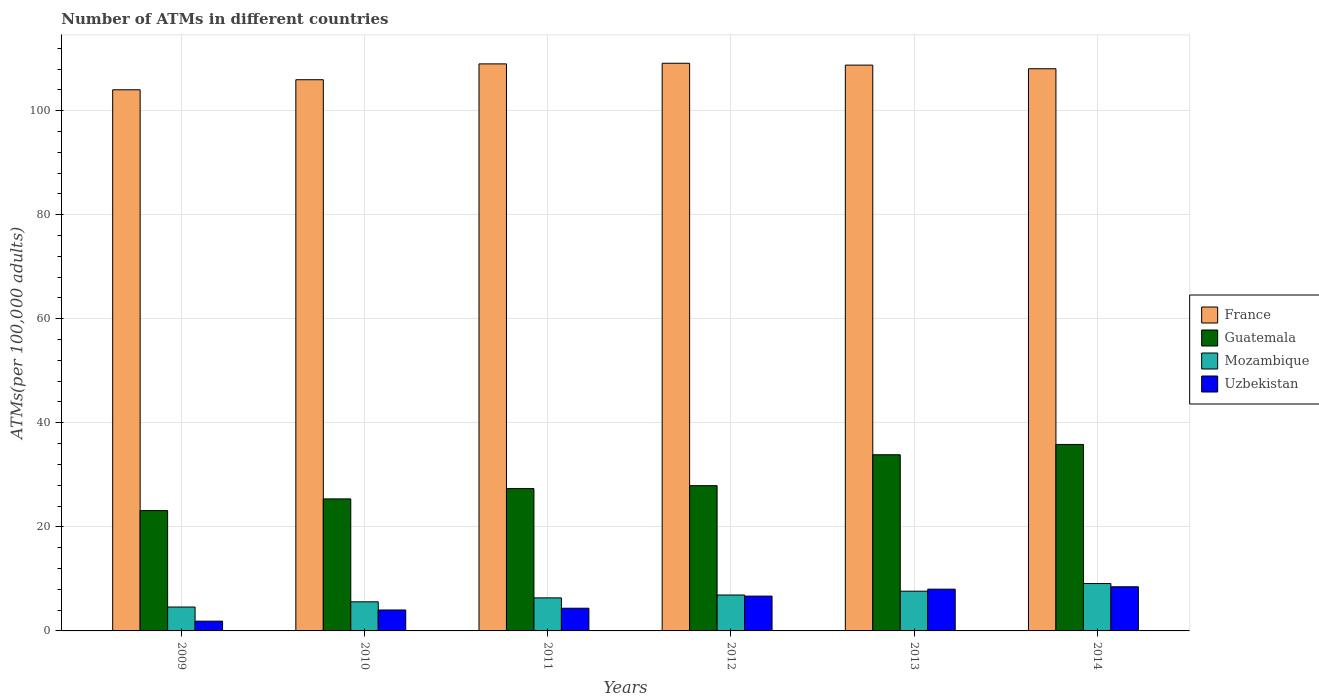How many groups of bars are there?
Offer a terse response. 6. How many bars are there on the 2nd tick from the right?
Give a very brief answer. 4. What is the number of ATMs in Mozambique in 2012?
Offer a terse response. 6.9. Across all years, what is the maximum number of ATMs in Mozambique?
Ensure brevity in your answer.  9.11. Across all years, what is the minimum number of ATMs in Uzbekistan?
Provide a short and direct response. 1.88. In which year was the number of ATMs in Uzbekistan maximum?
Your response must be concise. 2014. In which year was the number of ATMs in Guatemala minimum?
Ensure brevity in your answer.  2009. What is the total number of ATMs in Uzbekistan in the graph?
Offer a very short reply. 33.47. What is the difference between the number of ATMs in Guatemala in 2010 and that in 2012?
Your answer should be very brief. -2.55. What is the difference between the number of ATMs in Uzbekistan in 2010 and the number of ATMs in Mozambique in 2013?
Provide a succinct answer. -3.62. What is the average number of ATMs in Guatemala per year?
Your answer should be very brief. 28.91. In the year 2013, what is the difference between the number of ATMs in Guatemala and number of ATMs in Uzbekistan?
Offer a terse response. 25.83. What is the ratio of the number of ATMs in Uzbekistan in 2010 to that in 2014?
Offer a very short reply. 0.47. Is the difference between the number of ATMs in Guatemala in 2009 and 2014 greater than the difference between the number of ATMs in Uzbekistan in 2009 and 2014?
Offer a terse response. No. What is the difference between the highest and the second highest number of ATMs in France?
Ensure brevity in your answer.  0.12. What is the difference between the highest and the lowest number of ATMs in Mozambique?
Keep it short and to the point. 4.51. In how many years, is the number of ATMs in France greater than the average number of ATMs in France taken over all years?
Offer a very short reply. 4. Is the sum of the number of ATMs in France in 2011 and 2012 greater than the maximum number of ATMs in Guatemala across all years?
Your response must be concise. Yes. What does the 2nd bar from the left in 2010 represents?
Provide a short and direct response. Guatemala. Is it the case that in every year, the sum of the number of ATMs in Guatemala and number of ATMs in France is greater than the number of ATMs in Mozambique?
Provide a succinct answer. Yes. Are all the bars in the graph horizontal?
Ensure brevity in your answer.  No. Are the values on the major ticks of Y-axis written in scientific E-notation?
Keep it short and to the point. No. Does the graph contain any zero values?
Your answer should be compact. No. Does the graph contain grids?
Your response must be concise. Yes. How are the legend labels stacked?
Offer a very short reply. Vertical. What is the title of the graph?
Offer a terse response. Number of ATMs in different countries. What is the label or title of the Y-axis?
Make the answer very short. ATMs(per 100,0 adults). What is the ATMs(per 100,000 adults) of France in 2009?
Keep it short and to the point. 104.01. What is the ATMs(per 100,000 adults) in Guatemala in 2009?
Offer a very short reply. 23.12. What is the ATMs(per 100,000 adults) in Mozambique in 2009?
Offer a very short reply. 4.59. What is the ATMs(per 100,000 adults) in Uzbekistan in 2009?
Make the answer very short. 1.88. What is the ATMs(per 100,000 adults) of France in 2010?
Your response must be concise. 105.94. What is the ATMs(per 100,000 adults) of Guatemala in 2010?
Provide a short and direct response. 25.37. What is the ATMs(per 100,000 adults) of Mozambique in 2010?
Give a very brief answer. 5.6. What is the ATMs(per 100,000 adults) in Uzbekistan in 2010?
Keep it short and to the point. 4.02. What is the ATMs(per 100,000 adults) of France in 2011?
Your response must be concise. 108.99. What is the ATMs(per 100,000 adults) in Guatemala in 2011?
Offer a very short reply. 27.35. What is the ATMs(per 100,000 adults) in Mozambique in 2011?
Offer a terse response. 6.35. What is the ATMs(per 100,000 adults) of Uzbekistan in 2011?
Your answer should be very brief. 4.36. What is the ATMs(per 100,000 adults) of France in 2012?
Provide a succinct answer. 109.11. What is the ATMs(per 100,000 adults) in Guatemala in 2012?
Offer a terse response. 27.92. What is the ATMs(per 100,000 adults) of Mozambique in 2012?
Your response must be concise. 6.9. What is the ATMs(per 100,000 adults) in Uzbekistan in 2012?
Your response must be concise. 6.69. What is the ATMs(per 100,000 adults) of France in 2013?
Give a very brief answer. 108.75. What is the ATMs(per 100,000 adults) of Guatemala in 2013?
Keep it short and to the point. 33.86. What is the ATMs(per 100,000 adults) of Mozambique in 2013?
Offer a terse response. 7.64. What is the ATMs(per 100,000 adults) in Uzbekistan in 2013?
Give a very brief answer. 8.03. What is the ATMs(per 100,000 adults) in France in 2014?
Your answer should be compact. 108.05. What is the ATMs(per 100,000 adults) of Guatemala in 2014?
Provide a short and direct response. 35.84. What is the ATMs(per 100,000 adults) of Mozambique in 2014?
Ensure brevity in your answer.  9.11. What is the ATMs(per 100,000 adults) of Uzbekistan in 2014?
Give a very brief answer. 8.48. Across all years, what is the maximum ATMs(per 100,000 adults) in France?
Your answer should be compact. 109.11. Across all years, what is the maximum ATMs(per 100,000 adults) of Guatemala?
Make the answer very short. 35.84. Across all years, what is the maximum ATMs(per 100,000 adults) of Mozambique?
Offer a very short reply. 9.11. Across all years, what is the maximum ATMs(per 100,000 adults) of Uzbekistan?
Your answer should be very brief. 8.48. Across all years, what is the minimum ATMs(per 100,000 adults) of France?
Ensure brevity in your answer.  104.01. Across all years, what is the minimum ATMs(per 100,000 adults) of Guatemala?
Your answer should be compact. 23.12. Across all years, what is the minimum ATMs(per 100,000 adults) of Mozambique?
Make the answer very short. 4.59. Across all years, what is the minimum ATMs(per 100,000 adults) of Uzbekistan?
Offer a very short reply. 1.88. What is the total ATMs(per 100,000 adults) of France in the graph?
Offer a very short reply. 644.84. What is the total ATMs(per 100,000 adults) of Guatemala in the graph?
Provide a short and direct response. 173.47. What is the total ATMs(per 100,000 adults) in Mozambique in the graph?
Give a very brief answer. 40.19. What is the total ATMs(per 100,000 adults) in Uzbekistan in the graph?
Provide a succinct answer. 33.47. What is the difference between the ATMs(per 100,000 adults) in France in 2009 and that in 2010?
Provide a short and direct response. -1.93. What is the difference between the ATMs(per 100,000 adults) in Guatemala in 2009 and that in 2010?
Provide a short and direct response. -2.25. What is the difference between the ATMs(per 100,000 adults) in Mozambique in 2009 and that in 2010?
Give a very brief answer. -1. What is the difference between the ATMs(per 100,000 adults) in Uzbekistan in 2009 and that in 2010?
Give a very brief answer. -2.15. What is the difference between the ATMs(per 100,000 adults) in France in 2009 and that in 2011?
Give a very brief answer. -4.98. What is the difference between the ATMs(per 100,000 adults) of Guatemala in 2009 and that in 2011?
Make the answer very short. -4.23. What is the difference between the ATMs(per 100,000 adults) in Mozambique in 2009 and that in 2011?
Provide a succinct answer. -1.76. What is the difference between the ATMs(per 100,000 adults) in Uzbekistan in 2009 and that in 2011?
Provide a short and direct response. -2.49. What is the difference between the ATMs(per 100,000 adults) in France in 2009 and that in 2012?
Ensure brevity in your answer.  -5.1. What is the difference between the ATMs(per 100,000 adults) of Guatemala in 2009 and that in 2012?
Your answer should be compact. -4.8. What is the difference between the ATMs(per 100,000 adults) in Mozambique in 2009 and that in 2012?
Provide a succinct answer. -2.31. What is the difference between the ATMs(per 100,000 adults) of Uzbekistan in 2009 and that in 2012?
Your answer should be compact. -4.82. What is the difference between the ATMs(per 100,000 adults) in France in 2009 and that in 2013?
Provide a succinct answer. -4.74. What is the difference between the ATMs(per 100,000 adults) of Guatemala in 2009 and that in 2013?
Provide a succinct answer. -10.74. What is the difference between the ATMs(per 100,000 adults) in Mozambique in 2009 and that in 2013?
Ensure brevity in your answer.  -3.05. What is the difference between the ATMs(per 100,000 adults) of Uzbekistan in 2009 and that in 2013?
Your answer should be very brief. -6.15. What is the difference between the ATMs(per 100,000 adults) in France in 2009 and that in 2014?
Provide a short and direct response. -4.04. What is the difference between the ATMs(per 100,000 adults) in Guatemala in 2009 and that in 2014?
Your response must be concise. -12.72. What is the difference between the ATMs(per 100,000 adults) of Mozambique in 2009 and that in 2014?
Give a very brief answer. -4.51. What is the difference between the ATMs(per 100,000 adults) of Uzbekistan in 2009 and that in 2014?
Your answer should be compact. -6.61. What is the difference between the ATMs(per 100,000 adults) in France in 2010 and that in 2011?
Keep it short and to the point. -3.04. What is the difference between the ATMs(per 100,000 adults) in Guatemala in 2010 and that in 2011?
Your answer should be very brief. -1.98. What is the difference between the ATMs(per 100,000 adults) of Mozambique in 2010 and that in 2011?
Your answer should be compact. -0.76. What is the difference between the ATMs(per 100,000 adults) in Uzbekistan in 2010 and that in 2011?
Your answer should be very brief. -0.34. What is the difference between the ATMs(per 100,000 adults) in France in 2010 and that in 2012?
Offer a terse response. -3.17. What is the difference between the ATMs(per 100,000 adults) in Guatemala in 2010 and that in 2012?
Your response must be concise. -2.55. What is the difference between the ATMs(per 100,000 adults) in Mozambique in 2010 and that in 2012?
Your response must be concise. -1.31. What is the difference between the ATMs(per 100,000 adults) in Uzbekistan in 2010 and that in 2012?
Ensure brevity in your answer.  -2.67. What is the difference between the ATMs(per 100,000 adults) in France in 2010 and that in 2013?
Provide a short and direct response. -2.81. What is the difference between the ATMs(per 100,000 adults) of Guatemala in 2010 and that in 2013?
Your response must be concise. -8.49. What is the difference between the ATMs(per 100,000 adults) of Mozambique in 2010 and that in 2013?
Give a very brief answer. -2.04. What is the difference between the ATMs(per 100,000 adults) of Uzbekistan in 2010 and that in 2013?
Offer a terse response. -4. What is the difference between the ATMs(per 100,000 adults) of France in 2010 and that in 2014?
Keep it short and to the point. -2.11. What is the difference between the ATMs(per 100,000 adults) of Guatemala in 2010 and that in 2014?
Your response must be concise. -10.47. What is the difference between the ATMs(per 100,000 adults) in Mozambique in 2010 and that in 2014?
Your response must be concise. -3.51. What is the difference between the ATMs(per 100,000 adults) of Uzbekistan in 2010 and that in 2014?
Your answer should be very brief. -4.46. What is the difference between the ATMs(per 100,000 adults) of France in 2011 and that in 2012?
Keep it short and to the point. -0.12. What is the difference between the ATMs(per 100,000 adults) of Guatemala in 2011 and that in 2012?
Provide a succinct answer. -0.56. What is the difference between the ATMs(per 100,000 adults) in Mozambique in 2011 and that in 2012?
Make the answer very short. -0.55. What is the difference between the ATMs(per 100,000 adults) of Uzbekistan in 2011 and that in 2012?
Provide a short and direct response. -2.33. What is the difference between the ATMs(per 100,000 adults) in France in 2011 and that in 2013?
Provide a short and direct response. 0.24. What is the difference between the ATMs(per 100,000 adults) of Guatemala in 2011 and that in 2013?
Offer a terse response. -6.5. What is the difference between the ATMs(per 100,000 adults) of Mozambique in 2011 and that in 2013?
Ensure brevity in your answer.  -1.29. What is the difference between the ATMs(per 100,000 adults) of Uzbekistan in 2011 and that in 2013?
Make the answer very short. -3.66. What is the difference between the ATMs(per 100,000 adults) in France in 2011 and that in 2014?
Provide a succinct answer. 0.94. What is the difference between the ATMs(per 100,000 adults) in Guatemala in 2011 and that in 2014?
Offer a terse response. -8.49. What is the difference between the ATMs(per 100,000 adults) in Mozambique in 2011 and that in 2014?
Provide a short and direct response. -2.75. What is the difference between the ATMs(per 100,000 adults) of Uzbekistan in 2011 and that in 2014?
Your response must be concise. -4.12. What is the difference between the ATMs(per 100,000 adults) of France in 2012 and that in 2013?
Offer a very short reply. 0.36. What is the difference between the ATMs(per 100,000 adults) of Guatemala in 2012 and that in 2013?
Your response must be concise. -5.94. What is the difference between the ATMs(per 100,000 adults) in Mozambique in 2012 and that in 2013?
Your answer should be compact. -0.74. What is the difference between the ATMs(per 100,000 adults) in Uzbekistan in 2012 and that in 2013?
Your answer should be compact. -1.33. What is the difference between the ATMs(per 100,000 adults) in France in 2012 and that in 2014?
Ensure brevity in your answer.  1.06. What is the difference between the ATMs(per 100,000 adults) in Guatemala in 2012 and that in 2014?
Your answer should be very brief. -7.92. What is the difference between the ATMs(per 100,000 adults) of Mozambique in 2012 and that in 2014?
Make the answer very short. -2.21. What is the difference between the ATMs(per 100,000 adults) in Uzbekistan in 2012 and that in 2014?
Make the answer very short. -1.79. What is the difference between the ATMs(per 100,000 adults) of France in 2013 and that in 2014?
Your response must be concise. 0.7. What is the difference between the ATMs(per 100,000 adults) of Guatemala in 2013 and that in 2014?
Ensure brevity in your answer.  -1.98. What is the difference between the ATMs(per 100,000 adults) of Mozambique in 2013 and that in 2014?
Your answer should be very brief. -1.47. What is the difference between the ATMs(per 100,000 adults) in Uzbekistan in 2013 and that in 2014?
Your answer should be very brief. -0.46. What is the difference between the ATMs(per 100,000 adults) of France in 2009 and the ATMs(per 100,000 adults) of Guatemala in 2010?
Give a very brief answer. 78.63. What is the difference between the ATMs(per 100,000 adults) in France in 2009 and the ATMs(per 100,000 adults) in Mozambique in 2010?
Offer a very short reply. 98.41. What is the difference between the ATMs(per 100,000 adults) of France in 2009 and the ATMs(per 100,000 adults) of Uzbekistan in 2010?
Your answer should be very brief. 99.98. What is the difference between the ATMs(per 100,000 adults) of Guatemala in 2009 and the ATMs(per 100,000 adults) of Mozambique in 2010?
Offer a terse response. 17.53. What is the difference between the ATMs(per 100,000 adults) of Guatemala in 2009 and the ATMs(per 100,000 adults) of Uzbekistan in 2010?
Your answer should be compact. 19.1. What is the difference between the ATMs(per 100,000 adults) in Mozambique in 2009 and the ATMs(per 100,000 adults) in Uzbekistan in 2010?
Provide a short and direct response. 0.57. What is the difference between the ATMs(per 100,000 adults) in France in 2009 and the ATMs(per 100,000 adults) in Guatemala in 2011?
Provide a short and direct response. 76.65. What is the difference between the ATMs(per 100,000 adults) in France in 2009 and the ATMs(per 100,000 adults) in Mozambique in 2011?
Provide a short and direct response. 97.66. What is the difference between the ATMs(per 100,000 adults) in France in 2009 and the ATMs(per 100,000 adults) in Uzbekistan in 2011?
Provide a succinct answer. 99.65. What is the difference between the ATMs(per 100,000 adults) of Guatemala in 2009 and the ATMs(per 100,000 adults) of Mozambique in 2011?
Ensure brevity in your answer.  16.77. What is the difference between the ATMs(per 100,000 adults) in Guatemala in 2009 and the ATMs(per 100,000 adults) in Uzbekistan in 2011?
Provide a short and direct response. 18.76. What is the difference between the ATMs(per 100,000 adults) of Mozambique in 2009 and the ATMs(per 100,000 adults) of Uzbekistan in 2011?
Provide a succinct answer. 0.23. What is the difference between the ATMs(per 100,000 adults) of France in 2009 and the ATMs(per 100,000 adults) of Guatemala in 2012?
Give a very brief answer. 76.09. What is the difference between the ATMs(per 100,000 adults) in France in 2009 and the ATMs(per 100,000 adults) in Mozambique in 2012?
Your answer should be compact. 97.11. What is the difference between the ATMs(per 100,000 adults) in France in 2009 and the ATMs(per 100,000 adults) in Uzbekistan in 2012?
Ensure brevity in your answer.  97.31. What is the difference between the ATMs(per 100,000 adults) in Guatemala in 2009 and the ATMs(per 100,000 adults) in Mozambique in 2012?
Keep it short and to the point. 16.22. What is the difference between the ATMs(per 100,000 adults) in Guatemala in 2009 and the ATMs(per 100,000 adults) in Uzbekistan in 2012?
Keep it short and to the point. 16.43. What is the difference between the ATMs(per 100,000 adults) in Mozambique in 2009 and the ATMs(per 100,000 adults) in Uzbekistan in 2012?
Make the answer very short. -2.1. What is the difference between the ATMs(per 100,000 adults) in France in 2009 and the ATMs(per 100,000 adults) in Guatemala in 2013?
Ensure brevity in your answer.  70.15. What is the difference between the ATMs(per 100,000 adults) of France in 2009 and the ATMs(per 100,000 adults) of Mozambique in 2013?
Make the answer very short. 96.37. What is the difference between the ATMs(per 100,000 adults) in France in 2009 and the ATMs(per 100,000 adults) in Uzbekistan in 2013?
Give a very brief answer. 95.98. What is the difference between the ATMs(per 100,000 adults) of Guatemala in 2009 and the ATMs(per 100,000 adults) of Mozambique in 2013?
Your response must be concise. 15.48. What is the difference between the ATMs(per 100,000 adults) in Guatemala in 2009 and the ATMs(per 100,000 adults) in Uzbekistan in 2013?
Give a very brief answer. 15.1. What is the difference between the ATMs(per 100,000 adults) of Mozambique in 2009 and the ATMs(per 100,000 adults) of Uzbekistan in 2013?
Make the answer very short. -3.43. What is the difference between the ATMs(per 100,000 adults) of France in 2009 and the ATMs(per 100,000 adults) of Guatemala in 2014?
Provide a short and direct response. 68.17. What is the difference between the ATMs(per 100,000 adults) of France in 2009 and the ATMs(per 100,000 adults) of Mozambique in 2014?
Provide a short and direct response. 94.9. What is the difference between the ATMs(per 100,000 adults) of France in 2009 and the ATMs(per 100,000 adults) of Uzbekistan in 2014?
Offer a very short reply. 95.52. What is the difference between the ATMs(per 100,000 adults) in Guatemala in 2009 and the ATMs(per 100,000 adults) in Mozambique in 2014?
Your answer should be very brief. 14.02. What is the difference between the ATMs(per 100,000 adults) of Guatemala in 2009 and the ATMs(per 100,000 adults) of Uzbekistan in 2014?
Provide a short and direct response. 14.64. What is the difference between the ATMs(per 100,000 adults) in Mozambique in 2009 and the ATMs(per 100,000 adults) in Uzbekistan in 2014?
Your answer should be compact. -3.89. What is the difference between the ATMs(per 100,000 adults) of France in 2010 and the ATMs(per 100,000 adults) of Guatemala in 2011?
Keep it short and to the point. 78.59. What is the difference between the ATMs(per 100,000 adults) of France in 2010 and the ATMs(per 100,000 adults) of Mozambique in 2011?
Provide a succinct answer. 99.59. What is the difference between the ATMs(per 100,000 adults) of France in 2010 and the ATMs(per 100,000 adults) of Uzbekistan in 2011?
Provide a short and direct response. 101.58. What is the difference between the ATMs(per 100,000 adults) of Guatemala in 2010 and the ATMs(per 100,000 adults) of Mozambique in 2011?
Your response must be concise. 19.02. What is the difference between the ATMs(per 100,000 adults) in Guatemala in 2010 and the ATMs(per 100,000 adults) in Uzbekistan in 2011?
Offer a terse response. 21.01. What is the difference between the ATMs(per 100,000 adults) in Mozambique in 2010 and the ATMs(per 100,000 adults) in Uzbekistan in 2011?
Give a very brief answer. 1.23. What is the difference between the ATMs(per 100,000 adults) in France in 2010 and the ATMs(per 100,000 adults) in Guatemala in 2012?
Your answer should be very brief. 78.02. What is the difference between the ATMs(per 100,000 adults) in France in 2010 and the ATMs(per 100,000 adults) in Mozambique in 2012?
Offer a very short reply. 99.04. What is the difference between the ATMs(per 100,000 adults) in France in 2010 and the ATMs(per 100,000 adults) in Uzbekistan in 2012?
Keep it short and to the point. 99.25. What is the difference between the ATMs(per 100,000 adults) in Guatemala in 2010 and the ATMs(per 100,000 adults) in Mozambique in 2012?
Give a very brief answer. 18.47. What is the difference between the ATMs(per 100,000 adults) of Guatemala in 2010 and the ATMs(per 100,000 adults) of Uzbekistan in 2012?
Your response must be concise. 18.68. What is the difference between the ATMs(per 100,000 adults) in Mozambique in 2010 and the ATMs(per 100,000 adults) in Uzbekistan in 2012?
Provide a succinct answer. -1.1. What is the difference between the ATMs(per 100,000 adults) in France in 2010 and the ATMs(per 100,000 adults) in Guatemala in 2013?
Your answer should be compact. 72.08. What is the difference between the ATMs(per 100,000 adults) in France in 2010 and the ATMs(per 100,000 adults) in Mozambique in 2013?
Your response must be concise. 98.3. What is the difference between the ATMs(per 100,000 adults) in France in 2010 and the ATMs(per 100,000 adults) in Uzbekistan in 2013?
Ensure brevity in your answer.  97.91. What is the difference between the ATMs(per 100,000 adults) in Guatemala in 2010 and the ATMs(per 100,000 adults) in Mozambique in 2013?
Your answer should be very brief. 17.73. What is the difference between the ATMs(per 100,000 adults) in Guatemala in 2010 and the ATMs(per 100,000 adults) in Uzbekistan in 2013?
Your answer should be very brief. 17.35. What is the difference between the ATMs(per 100,000 adults) in Mozambique in 2010 and the ATMs(per 100,000 adults) in Uzbekistan in 2013?
Keep it short and to the point. -2.43. What is the difference between the ATMs(per 100,000 adults) of France in 2010 and the ATMs(per 100,000 adults) of Guatemala in 2014?
Make the answer very short. 70.1. What is the difference between the ATMs(per 100,000 adults) of France in 2010 and the ATMs(per 100,000 adults) of Mozambique in 2014?
Give a very brief answer. 96.83. What is the difference between the ATMs(per 100,000 adults) in France in 2010 and the ATMs(per 100,000 adults) in Uzbekistan in 2014?
Provide a succinct answer. 97.46. What is the difference between the ATMs(per 100,000 adults) in Guatemala in 2010 and the ATMs(per 100,000 adults) in Mozambique in 2014?
Give a very brief answer. 16.27. What is the difference between the ATMs(per 100,000 adults) of Guatemala in 2010 and the ATMs(per 100,000 adults) of Uzbekistan in 2014?
Make the answer very short. 16.89. What is the difference between the ATMs(per 100,000 adults) of Mozambique in 2010 and the ATMs(per 100,000 adults) of Uzbekistan in 2014?
Keep it short and to the point. -2.89. What is the difference between the ATMs(per 100,000 adults) in France in 2011 and the ATMs(per 100,000 adults) in Guatemala in 2012?
Provide a succinct answer. 81.07. What is the difference between the ATMs(per 100,000 adults) of France in 2011 and the ATMs(per 100,000 adults) of Mozambique in 2012?
Your answer should be compact. 102.08. What is the difference between the ATMs(per 100,000 adults) of France in 2011 and the ATMs(per 100,000 adults) of Uzbekistan in 2012?
Keep it short and to the point. 102.29. What is the difference between the ATMs(per 100,000 adults) in Guatemala in 2011 and the ATMs(per 100,000 adults) in Mozambique in 2012?
Give a very brief answer. 20.45. What is the difference between the ATMs(per 100,000 adults) of Guatemala in 2011 and the ATMs(per 100,000 adults) of Uzbekistan in 2012?
Offer a terse response. 20.66. What is the difference between the ATMs(per 100,000 adults) in Mozambique in 2011 and the ATMs(per 100,000 adults) in Uzbekistan in 2012?
Your answer should be very brief. -0.34. What is the difference between the ATMs(per 100,000 adults) in France in 2011 and the ATMs(per 100,000 adults) in Guatemala in 2013?
Keep it short and to the point. 75.13. What is the difference between the ATMs(per 100,000 adults) of France in 2011 and the ATMs(per 100,000 adults) of Mozambique in 2013?
Give a very brief answer. 101.35. What is the difference between the ATMs(per 100,000 adults) in France in 2011 and the ATMs(per 100,000 adults) in Uzbekistan in 2013?
Your answer should be very brief. 100.96. What is the difference between the ATMs(per 100,000 adults) of Guatemala in 2011 and the ATMs(per 100,000 adults) of Mozambique in 2013?
Ensure brevity in your answer.  19.71. What is the difference between the ATMs(per 100,000 adults) in Guatemala in 2011 and the ATMs(per 100,000 adults) in Uzbekistan in 2013?
Provide a succinct answer. 19.33. What is the difference between the ATMs(per 100,000 adults) of Mozambique in 2011 and the ATMs(per 100,000 adults) of Uzbekistan in 2013?
Offer a very short reply. -1.67. What is the difference between the ATMs(per 100,000 adults) of France in 2011 and the ATMs(per 100,000 adults) of Guatemala in 2014?
Provide a succinct answer. 73.14. What is the difference between the ATMs(per 100,000 adults) of France in 2011 and the ATMs(per 100,000 adults) of Mozambique in 2014?
Keep it short and to the point. 99.88. What is the difference between the ATMs(per 100,000 adults) in France in 2011 and the ATMs(per 100,000 adults) in Uzbekistan in 2014?
Offer a very short reply. 100.5. What is the difference between the ATMs(per 100,000 adults) in Guatemala in 2011 and the ATMs(per 100,000 adults) in Mozambique in 2014?
Provide a short and direct response. 18.25. What is the difference between the ATMs(per 100,000 adults) of Guatemala in 2011 and the ATMs(per 100,000 adults) of Uzbekistan in 2014?
Provide a succinct answer. 18.87. What is the difference between the ATMs(per 100,000 adults) of Mozambique in 2011 and the ATMs(per 100,000 adults) of Uzbekistan in 2014?
Give a very brief answer. -2.13. What is the difference between the ATMs(per 100,000 adults) of France in 2012 and the ATMs(per 100,000 adults) of Guatemala in 2013?
Give a very brief answer. 75.25. What is the difference between the ATMs(per 100,000 adults) of France in 2012 and the ATMs(per 100,000 adults) of Mozambique in 2013?
Offer a terse response. 101.47. What is the difference between the ATMs(per 100,000 adults) of France in 2012 and the ATMs(per 100,000 adults) of Uzbekistan in 2013?
Ensure brevity in your answer.  101.08. What is the difference between the ATMs(per 100,000 adults) in Guatemala in 2012 and the ATMs(per 100,000 adults) in Mozambique in 2013?
Your response must be concise. 20.28. What is the difference between the ATMs(per 100,000 adults) in Guatemala in 2012 and the ATMs(per 100,000 adults) in Uzbekistan in 2013?
Give a very brief answer. 19.89. What is the difference between the ATMs(per 100,000 adults) in Mozambique in 2012 and the ATMs(per 100,000 adults) in Uzbekistan in 2013?
Make the answer very short. -1.12. What is the difference between the ATMs(per 100,000 adults) in France in 2012 and the ATMs(per 100,000 adults) in Guatemala in 2014?
Offer a very short reply. 73.27. What is the difference between the ATMs(per 100,000 adults) of France in 2012 and the ATMs(per 100,000 adults) of Mozambique in 2014?
Your answer should be compact. 100. What is the difference between the ATMs(per 100,000 adults) in France in 2012 and the ATMs(per 100,000 adults) in Uzbekistan in 2014?
Keep it short and to the point. 100.62. What is the difference between the ATMs(per 100,000 adults) of Guatemala in 2012 and the ATMs(per 100,000 adults) of Mozambique in 2014?
Offer a very short reply. 18.81. What is the difference between the ATMs(per 100,000 adults) in Guatemala in 2012 and the ATMs(per 100,000 adults) in Uzbekistan in 2014?
Provide a short and direct response. 19.44. What is the difference between the ATMs(per 100,000 adults) of Mozambique in 2012 and the ATMs(per 100,000 adults) of Uzbekistan in 2014?
Your answer should be very brief. -1.58. What is the difference between the ATMs(per 100,000 adults) of France in 2013 and the ATMs(per 100,000 adults) of Guatemala in 2014?
Your answer should be compact. 72.91. What is the difference between the ATMs(per 100,000 adults) of France in 2013 and the ATMs(per 100,000 adults) of Mozambique in 2014?
Keep it short and to the point. 99.64. What is the difference between the ATMs(per 100,000 adults) of France in 2013 and the ATMs(per 100,000 adults) of Uzbekistan in 2014?
Your answer should be very brief. 100.27. What is the difference between the ATMs(per 100,000 adults) in Guatemala in 2013 and the ATMs(per 100,000 adults) in Mozambique in 2014?
Ensure brevity in your answer.  24.75. What is the difference between the ATMs(per 100,000 adults) of Guatemala in 2013 and the ATMs(per 100,000 adults) of Uzbekistan in 2014?
Offer a very short reply. 25.38. What is the difference between the ATMs(per 100,000 adults) of Mozambique in 2013 and the ATMs(per 100,000 adults) of Uzbekistan in 2014?
Keep it short and to the point. -0.84. What is the average ATMs(per 100,000 adults) in France per year?
Offer a very short reply. 107.47. What is the average ATMs(per 100,000 adults) of Guatemala per year?
Provide a succinct answer. 28.91. What is the average ATMs(per 100,000 adults) of Mozambique per year?
Your answer should be very brief. 6.7. What is the average ATMs(per 100,000 adults) in Uzbekistan per year?
Offer a very short reply. 5.58. In the year 2009, what is the difference between the ATMs(per 100,000 adults) in France and ATMs(per 100,000 adults) in Guatemala?
Give a very brief answer. 80.89. In the year 2009, what is the difference between the ATMs(per 100,000 adults) of France and ATMs(per 100,000 adults) of Mozambique?
Keep it short and to the point. 99.42. In the year 2009, what is the difference between the ATMs(per 100,000 adults) in France and ATMs(per 100,000 adults) in Uzbekistan?
Your answer should be very brief. 102.13. In the year 2009, what is the difference between the ATMs(per 100,000 adults) in Guatemala and ATMs(per 100,000 adults) in Mozambique?
Provide a succinct answer. 18.53. In the year 2009, what is the difference between the ATMs(per 100,000 adults) of Guatemala and ATMs(per 100,000 adults) of Uzbekistan?
Offer a very short reply. 21.25. In the year 2009, what is the difference between the ATMs(per 100,000 adults) in Mozambique and ATMs(per 100,000 adults) in Uzbekistan?
Offer a very short reply. 2.72. In the year 2010, what is the difference between the ATMs(per 100,000 adults) in France and ATMs(per 100,000 adults) in Guatemala?
Your response must be concise. 80.57. In the year 2010, what is the difference between the ATMs(per 100,000 adults) in France and ATMs(per 100,000 adults) in Mozambique?
Ensure brevity in your answer.  100.34. In the year 2010, what is the difference between the ATMs(per 100,000 adults) of France and ATMs(per 100,000 adults) of Uzbekistan?
Make the answer very short. 101.92. In the year 2010, what is the difference between the ATMs(per 100,000 adults) of Guatemala and ATMs(per 100,000 adults) of Mozambique?
Your answer should be compact. 19.78. In the year 2010, what is the difference between the ATMs(per 100,000 adults) in Guatemala and ATMs(per 100,000 adults) in Uzbekistan?
Offer a terse response. 21.35. In the year 2010, what is the difference between the ATMs(per 100,000 adults) in Mozambique and ATMs(per 100,000 adults) in Uzbekistan?
Your response must be concise. 1.57. In the year 2011, what is the difference between the ATMs(per 100,000 adults) of France and ATMs(per 100,000 adults) of Guatemala?
Make the answer very short. 81.63. In the year 2011, what is the difference between the ATMs(per 100,000 adults) of France and ATMs(per 100,000 adults) of Mozambique?
Your answer should be very brief. 102.63. In the year 2011, what is the difference between the ATMs(per 100,000 adults) in France and ATMs(per 100,000 adults) in Uzbekistan?
Offer a terse response. 104.62. In the year 2011, what is the difference between the ATMs(per 100,000 adults) in Guatemala and ATMs(per 100,000 adults) in Mozambique?
Your answer should be compact. 21. In the year 2011, what is the difference between the ATMs(per 100,000 adults) in Guatemala and ATMs(per 100,000 adults) in Uzbekistan?
Provide a short and direct response. 22.99. In the year 2011, what is the difference between the ATMs(per 100,000 adults) of Mozambique and ATMs(per 100,000 adults) of Uzbekistan?
Give a very brief answer. 1.99. In the year 2012, what is the difference between the ATMs(per 100,000 adults) in France and ATMs(per 100,000 adults) in Guatemala?
Provide a succinct answer. 81.19. In the year 2012, what is the difference between the ATMs(per 100,000 adults) in France and ATMs(per 100,000 adults) in Mozambique?
Offer a very short reply. 102.2. In the year 2012, what is the difference between the ATMs(per 100,000 adults) in France and ATMs(per 100,000 adults) in Uzbekistan?
Provide a short and direct response. 102.41. In the year 2012, what is the difference between the ATMs(per 100,000 adults) of Guatemala and ATMs(per 100,000 adults) of Mozambique?
Make the answer very short. 21.02. In the year 2012, what is the difference between the ATMs(per 100,000 adults) of Guatemala and ATMs(per 100,000 adults) of Uzbekistan?
Provide a succinct answer. 21.23. In the year 2012, what is the difference between the ATMs(per 100,000 adults) in Mozambique and ATMs(per 100,000 adults) in Uzbekistan?
Offer a terse response. 0.21. In the year 2013, what is the difference between the ATMs(per 100,000 adults) in France and ATMs(per 100,000 adults) in Guatemala?
Provide a short and direct response. 74.89. In the year 2013, what is the difference between the ATMs(per 100,000 adults) in France and ATMs(per 100,000 adults) in Mozambique?
Make the answer very short. 101.11. In the year 2013, what is the difference between the ATMs(per 100,000 adults) of France and ATMs(per 100,000 adults) of Uzbekistan?
Offer a very short reply. 100.72. In the year 2013, what is the difference between the ATMs(per 100,000 adults) of Guatemala and ATMs(per 100,000 adults) of Mozambique?
Offer a very short reply. 26.22. In the year 2013, what is the difference between the ATMs(per 100,000 adults) in Guatemala and ATMs(per 100,000 adults) in Uzbekistan?
Make the answer very short. 25.83. In the year 2013, what is the difference between the ATMs(per 100,000 adults) of Mozambique and ATMs(per 100,000 adults) of Uzbekistan?
Your response must be concise. -0.39. In the year 2014, what is the difference between the ATMs(per 100,000 adults) of France and ATMs(per 100,000 adults) of Guatemala?
Keep it short and to the point. 72.21. In the year 2014, what is the difference between the ATMs(per 100,000 adults) in France and ATMs(per 100,000 adults) in Mozambique?
Your answer should be compact. 98.94. In the year 2014, what is the difference between the ATMs(per 100,000 adults) of France and ATMs(per 100,000 adults) of Uzbekistan?
Provide a short and direct response. 99.56. In the year 2014, what is the difference between the ATMs(per 100,000 adults) in Guatemala and ATMs(per 100,000 adults) in Mozambique?
Your answer should be compact. 26.73. In the year 2014, what is the difference between the ATMs(per 100,000 adults) in Guatemala and ATMs(per 100,000 adults) in Uzbekistan?
Offer a terse response. 27.36. In the year 2014, what is the difference between the ATMs(per 100,000 adults) in Mozambique and ATMs(per 100,000 adults) in Uzbekistan?
Give a very brief answer. 0.62. What is the ratio of the ATMs(per 100,000 adults) in France in 2009 to that in 2010?
Make the answer very short. 0.98. What is the ratio of the ATMs(per 100,000 adults) in Guatemala in 2009 to that in 2010?
Give a very brief answer. 0.91. What is the ratio of the ATMs(per 100,000 adults) in Mozambique in 2009 to that in 2010?
Give a very brief answer. 0.82. What is the ratio of the ATMs(per 100,000 adults) in Uzbekistan in 2009 to that in 2010?
Your answer should be very brief. 0.47. What is the ratio of the ATMs(per 100,000 adults) in France in 2009 to that in 2011?
Your response must be concise. 0.95. What is the ratio of the ATMs(per 100,000 adults) in Guatemala in 2009 to that in 2011?
Provide a succinct answer. 0.85. What is the ratio of the ATMs(per 100,000 adults) of Mozambique in 2009 to that in 2011?
Your answer should be very brief. 0.72. What is the ratio of the ATMs(per 100,000 adults) in Uzbekistan in 2009 to that in 2011?
Your response must be concise. 0.43. What is the ratio of the ATMs(per 100,000 adults) in France in 2009 to that in 2012?
Offer a very short reply. 0.95. What is the ratio of the ATMs(per 100,000 adults) of Guatemala in 2009 to that in 2012?
Your answer should be very brief. 0.83. What is the ratio of the ATMs(per 100,000 adults) of Mozambique in 2009 to that in 2012?
Give a very brief answer. 0.67. What is the ratio of the ATMs(per 100,000 adults) in Uzbekistan in 2009 to that in 2012?
Your answer should be very brief. 0.28. What is the ratio of the ATMs(per 100,000 adults) of France in 2009 to that in 2013?
Your answer should be compact. 0.96. What is the ratio of the ATMs(per 100,000 adults) in Guatemala in 2009 to that in 2013?
Your answer should be compact. 0.68. What is the ratio of the ATMs(per 100,000 adults) in Mozambique in 2009 to that in 2013?
Your answer should be very brief. 0.6. What is the ratio of the ATMs(per 100,000 adults) in Uzbekistan in 2009 to that in 2013?
Keep it short and to the point. 0.23. What is the ratio of the ATMs(per 100,000 adults) of France in 2009 to that in 2014?
Make the answer very short. 0.96. What is the ratio of the ATMs(per 100,000 adults) in Guatemala in 2009 to that in 2014?
Offer a terse response. 0.65. What is the ratio of the ATMs(per 100,000 adults) in Mozambique in 2009 to that in 2014?
Your response must be concise. 0.5. What is the ratio of the ATMs(per 100,000 adults) in Uzbekistan in 2009 to that in 2014?
Your answer should be compact. 0.22. What is the ratio of the ATMs(per 100,000 adults) in France in 2010 to that in 2011?
Offer a very short reply. 0.97. What is the ratio of the ATMs(per 100,000 adults) of Guatemala in 2010 to that in 2011?
Keep it short and to the point. 0.93. What is the ratio of the ATMs(per 100,000 adults) in Mozambique in 2010 to that in 2011?
Your response must be concise. 0.88. What is the ratio of the ATMs(per 100,000 adults) in Uzbekistan in 2010 to that in 2011?
Your answer should be compact. 0.92. What is the ratio of the ATMs(per 100,000 adults) in France in 2010 to that in 2012?
Offer a terse response. 0.97. What is the ratio of the ATMs(per 100,000 adults) in Guatemala in 2010 to that in 2012?
Provide a succinct answer. 0.91. What is the ratio of the ATMs(per 100,000 adults) in Mozambique in 2010 to that in 2012?
Offer a terse response. 0.81. What is the ratio of the ATMs(per 100,000 adults) of Uzbekistan in 2010 to that in 2012?
Your response must be concise. 0.6. What is the ratio of the ATMs(per 100,000 adults) of France in 2010 to that in 2013?
Give a very brief answer. 0.97. What is the ratio of the ATMs(per 100,000 adults) in Guatemala in 2010 to that in 2013?
Ensure brevity in your answer.  0.75. What is the ratio of the ATMs(per 100,000 adults) in Mozambique in 2010 to that in 2013?
Provide a short and direct response. 0.73. What is the ratio of the ATMs(per 100,000 adults) of Uzbekistan in 2010 to that in 2013?
Give a very brief answer. 0.5. What is the ratio of the ATMs(per 100,000 adults) of France in 2010 to that in 2014?
Offer a very short reply. 0.98. What is the ratio of the ATMs(per 100,000 adults) of Guatemala in 2010 to that in 2014?
Your answer should be very brief. 0.71. What is the ratio of the ATMs(per 100,000 adults) of Mozambique in 2010 to that in 2014?
Offer a terse response. 0.61. What is the ratio of the ATMs(per 100,000 adults) in Uzbekistan in 2010 to that in 2014?
Offer a terse response. 0.47. What is the ratio of the ATMs(per 100,000 adults) of Guatemala in 2011 to that in 2012?
Keep it short and to the point. 0.98. What is the ratio of the ATMs(per 100,000 adults) of Mozambique in 2011 to that in 2012?
Provide a succinct answer. 0.92. What is the ratio of the ATMs(per 100,000 adults) of Uzbekistan in 2011 to that in 2012?
Ensure brevity in your answer.  0.65. What is the ratio of the ATMs(per 100,000 adults) of France in 2011 to that in 2013?
Keep it short and to the point. 1. What is the ratio of the ATMs(per 100,000 adults) in Guatemala in 2011 to that in 2013?
Provide a short and direct response. 0.81. What is the ratio of the ATMs(per 100,000 adults) of Mozambique in 2011 to that in 2013?
Offer a very short reply. 0.83. What is the ratio of the ATMs(per 100,000 adults) in Uzbekistan in 2011 to that in 2013?
Offer a terse response. 0.54. What is the ratio of the ATMs(per 100,000 adults) of France in 2011 to that in 2014?
Offer a very short reply. 1.01. What is the ratio of the ATMs(per 100,000 adults) of Guatemala in 2011 to that in 2014?
Your answer should be compact. 0.76. What is the ratio of the ATMs(per 100,000 adults) in Mozambique in 2011 to that in 2014?
Your response must be concise. 0.7. What is the ratio of the ATMs(per 100,000 adults) in Uzbekistan in 2011 to that in 2014?
Offer a very short reply. 0.51. What is the ratio of the ATMs(per 100,000 adults) of Guatemala in 2012 to that in 2013?
Offer a terse response. 0.82. What is the ratio of the ATMs(per 100,000 adults) in Mozambique in 2012 to that in 2013?
Make the answer very short. 0.9. What is the ratio of the ATMs(per 100,000 adults) of Uzbekistan in 2012 to that in 2013?
Keep it short and to the point. 0.83. What is the ratio of the ATMs(per 100,000 adults) in France in 2012 to that in 2014?
Your answer should be compact. 1.01. What is the ratio of the ATMs(per 100,000 adults) in Guatemala in 2012 to that in 2014?
Offer a terse response. 0.78. What is the ratio of the ATMs(per 100,000 adults) in Mozambique in 2012 to that in 2014?
Your answer should be compact. 0.76. What is the ratio of the ATMs(per 100,000 adults) of Uzbekistan in 2012 to that in 2014?
Ensure brevity in your answer.  0.79. What is the ratio of the ATMs(per 100,000 adults) in Guatemala in 2013 to that in 2014?
Keep it short and to the point. 0.94. What is the ratio of the ATMs(per 100,000 adults) of Mozambique in 2013 to that in 2014?
Provide a short and direct response. 0.84. What is the ratio of the ATMs(per 100,000 adults) of Uzbekistan in 2013 to that in 2014?
Give a very brief answer. 0.95. What is the difference between the highest and the second highest ATMs(per 100,000 adults) in France?
Ensure brevity in your answer.  0.12. What is the difference between the highest and the second highest ATMs(per 100,000 adults) of Guatemala?
Ensure brevity in your answer.  1.98. What is the difference between the highest and the second highest ATMs(per 100,000 adults) of Mozambique?
Offer a very short reply. 1.47. What is the difference between the highest and the second highest ATMs(per 100,000 adults) in Uzbekistan?
Offer a very short reply. 0.46. What is the difference between the highest and the lowest ATMs(per 100,000 adults) in France?
Offer a very short reply. 5.1. What is the difference between the highest and the lowest ATMs(per 100,000 adults) of Guatemala?
Give a very brief answer. 12.72. What is the difference between the highest and the lowest ATMs(per 100,000 adults) of Mozambique?
Your response must be concise. 4.51. What is the difference between the highest and the lowest ATMs(per 100,000 adults) in Uzbekistan?
Make the answer very short. 6.61. 